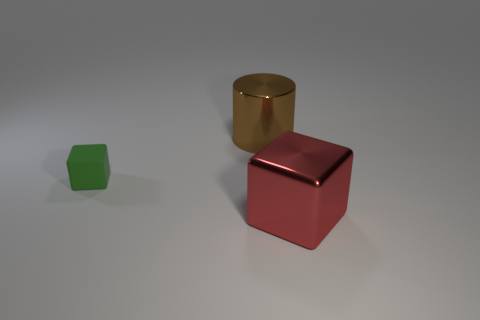Are there any other things that are the same size as the matte object?
Your answer should be very brief. No. Do the red metallic thing and the small thing that is behind the big red metallic object have the same shape?
Give a very brief answer. Yes. Are any metallic cylinders visible?
Offer a very short reply. Yes. Are there any objects made of the same material as the brown cylinder?
Your answer should be compact. Yes. Is there any other thing that is made of the same material as the small object?
Keep it short and to the point. No. The cylinder is what color?
Keep it short and to the point. Brown. The metal cylinder that is the same size as the red metal object is what color?
Keep it short and to the point. Brown. What number of matte objects are big brown things or tiny purple cylinders?
Keep it short and to the point. 0. How many large things are in front of the green block and behind the big red shiny thing?
Offer a terse response. 0. Is there any other thing that is the same shape as the green rubber thing?
Keep it short and to the point. Yes. 